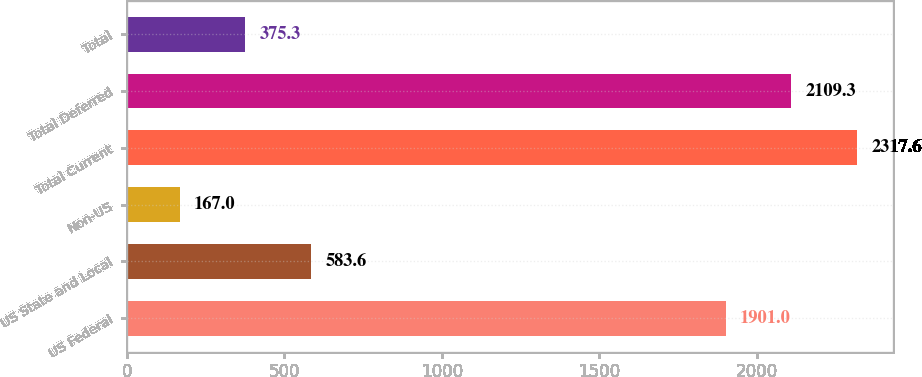Convert chart to OTSL. <chart><loc_0><loc_0><loc_500><loc_500><bar_chart><fcel>US Federal<fcel>US State and Local<fcel>Non-US<fcel>Total Current<fcel>Total Deferred<fcel>Total<nl><fcel>1901<fcel>583.6<fcel>167<fcel>2317.6<fcel>2109.3<fcel>375.3<nl></chart> 